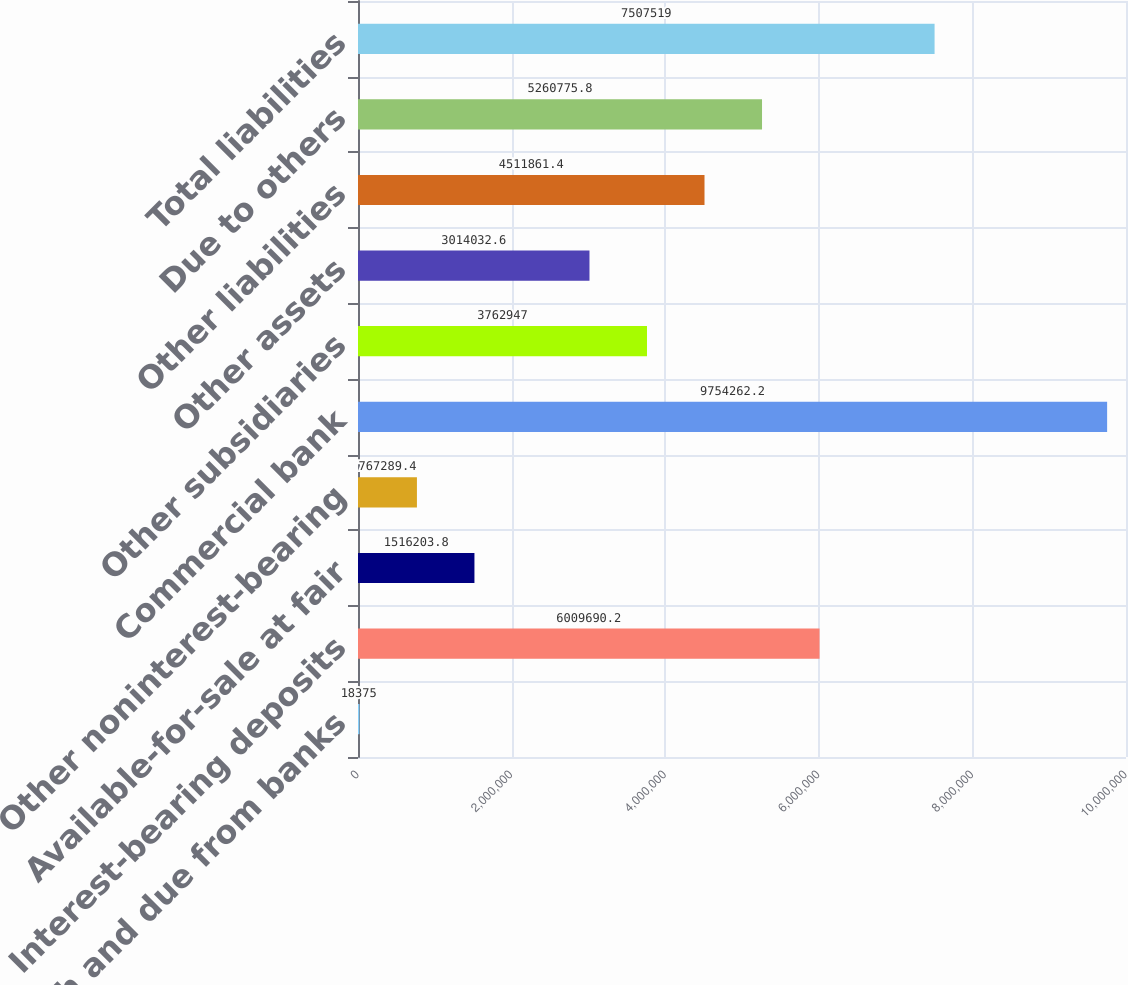Convert chart to OTSL. <chart><loc_0><loc_0><loc_500><loc_500><bar_chart><fcel>Cash and due from banks<fcel>Interest-bearing deposits<fcel>Available-for-sale at fair<fcel>Other noninterest-bearing<fcel>Commercial bank<fcel>Other subsidiaries<fcel>Other assets<fcel>Other liabilities<fcel>Due to others<fcel>Total liabilities<nl><fcel>18375<fcel>6.00969e+06<fcel>1.5162e+06<fcel>767289<fcel>9.75426e+06<fcel>3.76295e+06<fcel>3.01403e+06<fcel>4.51186e+06<fcel>5.26078e+06<fcel>7.50752e+06<nl></chart> 